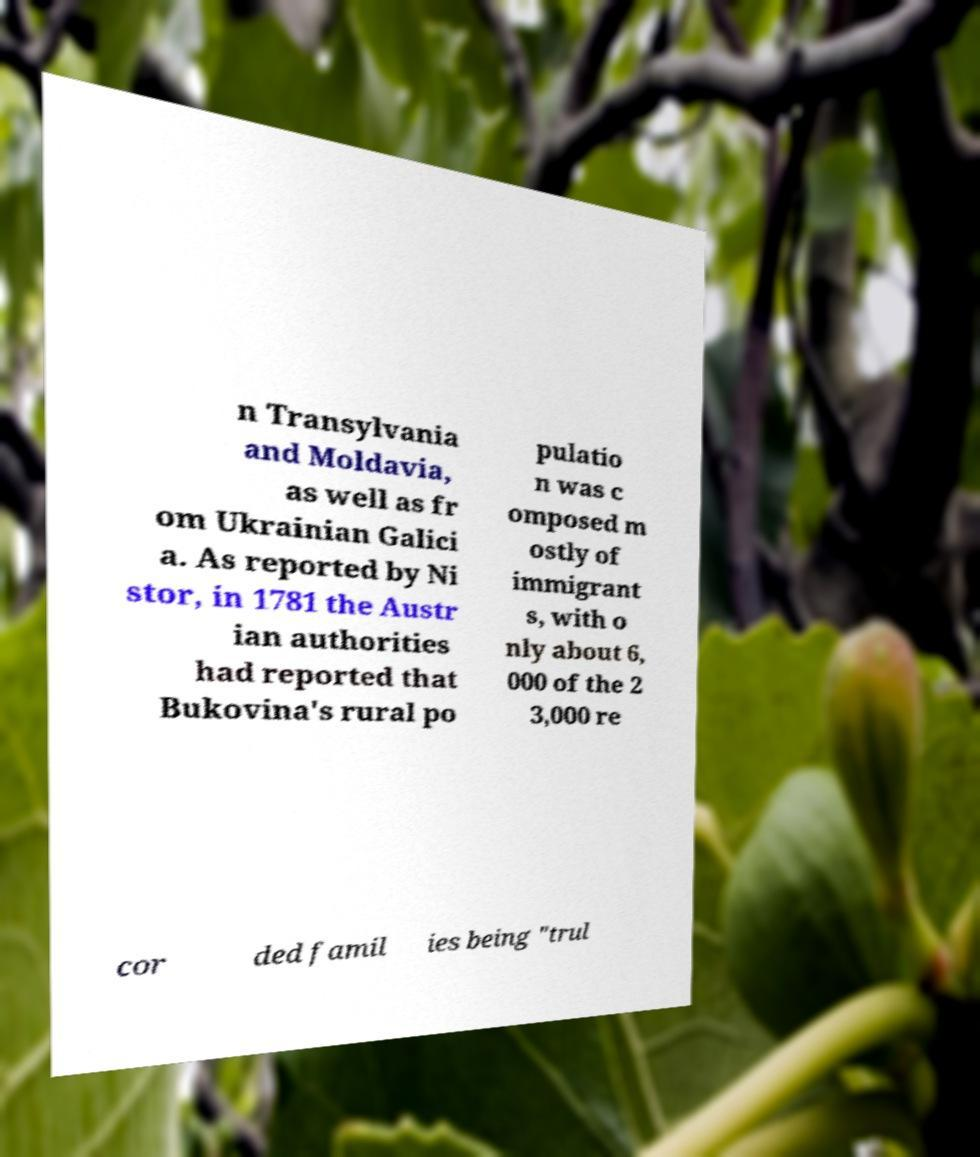Can you accurately transcribe the text from the provided image for me? n Transylvania and Moldavia, as well as fr om Ukrainian Galici a. As reported by Ni stor, in 1781 the Austr ian authorities had reported that Bukovina's rural po pulatio n was c omposed m ostly of immigrant s, with o nly about 6, 000 of the 2 3,000 re cor ded famil ies being "trul 